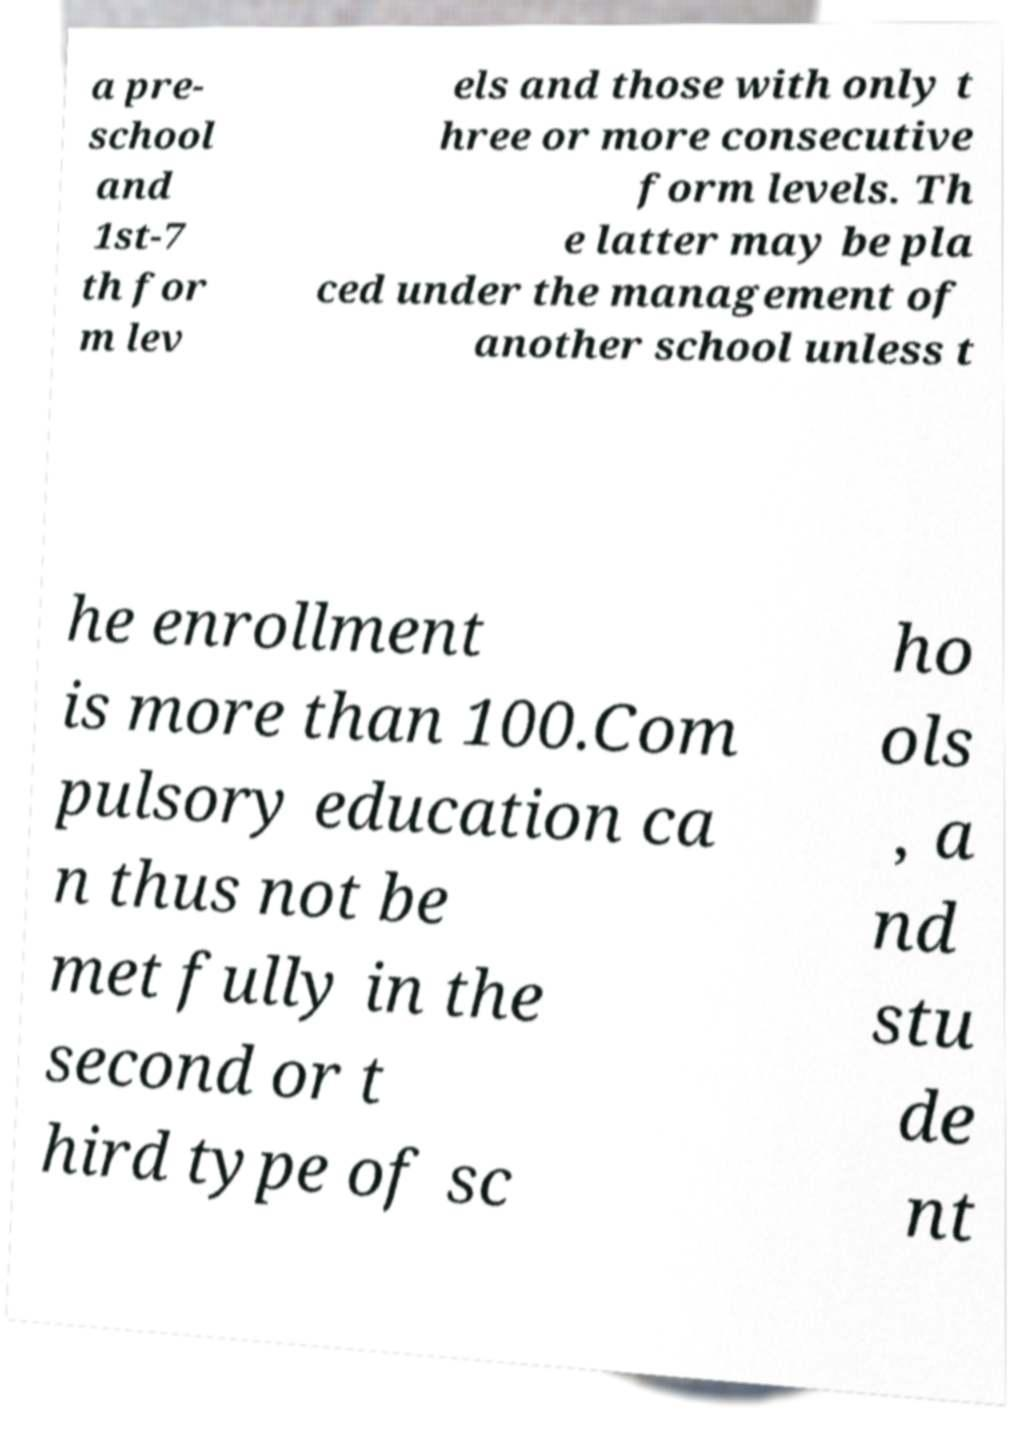Could you extract and type out the text from this image? a pre- school and 1st-7 th for m lev els and those with only t hree or more consecutive form levels. Th e latter may be pla ced under the management of another school unless t he enrollment is more than 100.Com pulsory education ca n thus not be met fully in the second or t hird type of sc ho ols , a nd stu de nt 